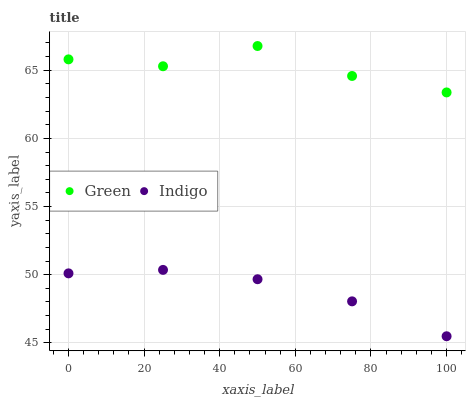Does Indigo have the minimum area under the curve?
Answer yes or no. Yes. Does Green have the maximum area under the curve?
Answer yes or no. Yes. Does Green have the minimum area under the curve?
Answer yes or no. No. Is Indigo the smoothest?
Answer yes or no. Yes. Is Green the roughest?
Answer yes or no. Yes. Is Green the smoothest?
Answer yes or no. No. Does Indigo have the lowest value?
Answer yes or no. Yes. Does Green have the lowest value?
Answer yes or no. No. Does Green have the highest value?
Answer yes or no. Yes. Is Indigo less than Green?
Answer yes or no. Yes. Is Green greater than Indigo?
Answer yes or no. Yes. Does Indigo intersect Green?
Answer yes or no. No. 